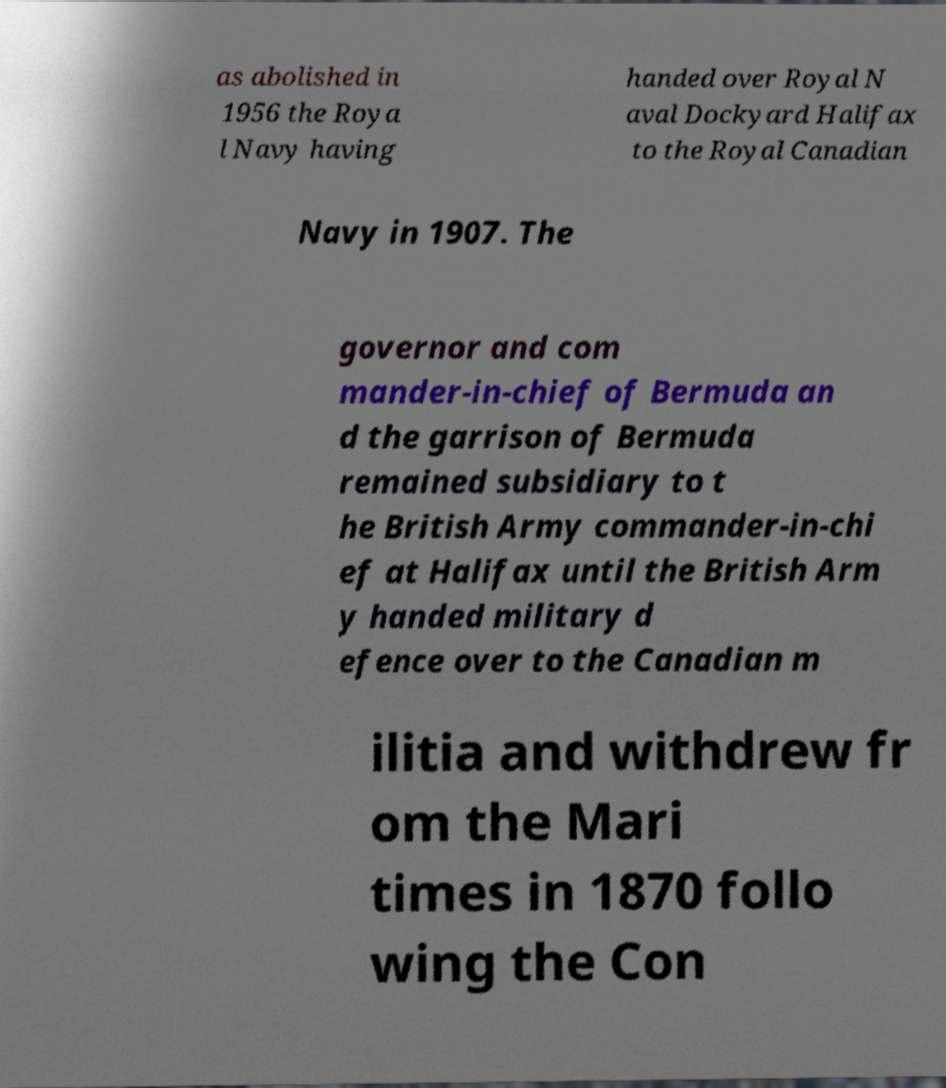For documentation purposes, I need the text within this image transcribed. Could you provide that? as abolished in 1956 the Roya l Navy having handed over Royal N aval Dockyard Halifax to the Royal Canadian Navy in 1907. The governor and com mander-in-chief of Bermuda an d the garrison of Bermuda remained subsidiary to t he British Army commander-in-chi ef at Halifax until the British Arm y handed military d efence over to the Canadian m ilitia and withdrew fr om the Mari times in 1870 follo wing the Con 